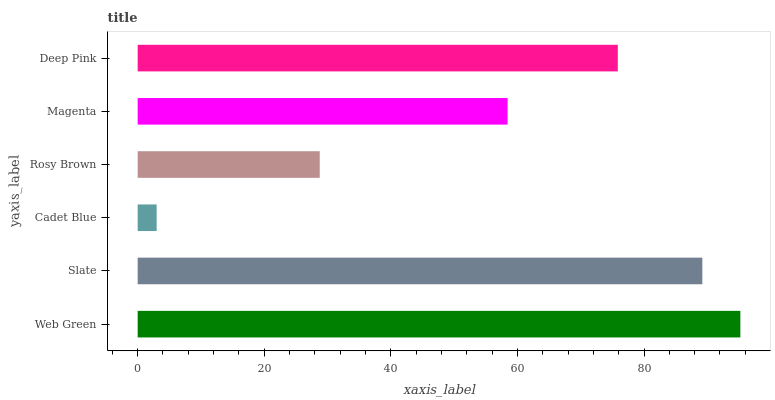Is Cadet Blue the minimum?
Answer yes or no. Yes. Is Web Green the maximum?
Answer yes or no. Yes. Is Slate the minimum?
Answer yes or no. No. Is Slate the maximum?
Answer yes or no. No. Is Web Green greater than Slate?
Answer yes or no. Yes. Is Slate less than Web Green?
Answer yes or no. Yes. Is Slate greater than Web Green?
Answer yes or no. No. Is Web Green less than Slate?
Answer yes or no. No. Is Deep Pink the high median?
Answer yes or no. Yes. Is Magenta the low median?
Answer yes or no. Yes. Is Slate the high median?
Answer yes or no. No. Is Cadet Blue the low median?
Answer yes or no. No. 